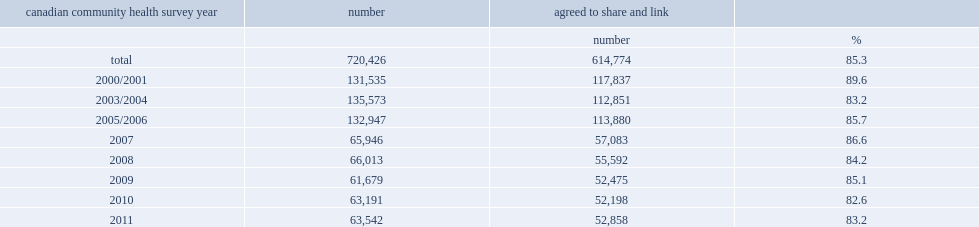Overall, what percentage of of cchs respondents were eligible for linkage? 85.3. 